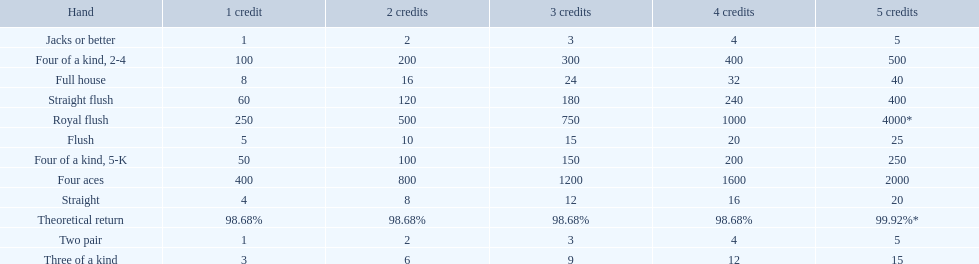What is the values in the 5 credits area? 4000*, 400, 2000, 500, 250, 40, 25, 20, 15, 5, 5. Which of these is for a four of a kind? 500, 250. What is the higher value? 500. What hand is this for Four of a kind, 2-4. 